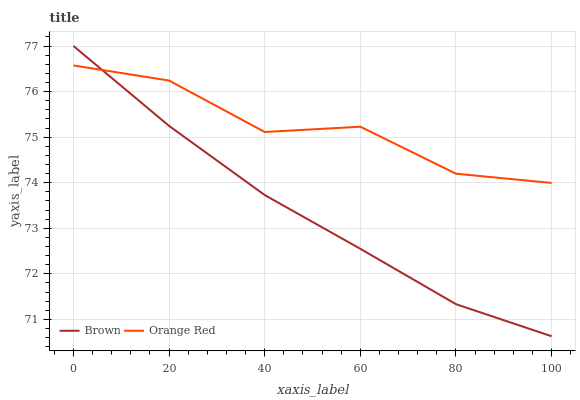Does Orange Red have the minimum area under the curve?
Answer yes or no. No. Is Orange Red the smoothest?
Answer yes or no. No. Does Orange Red have the lowest value?
Answer yes or no. No. Does Orange Red have the highest value?
Answer yes or no. No. 